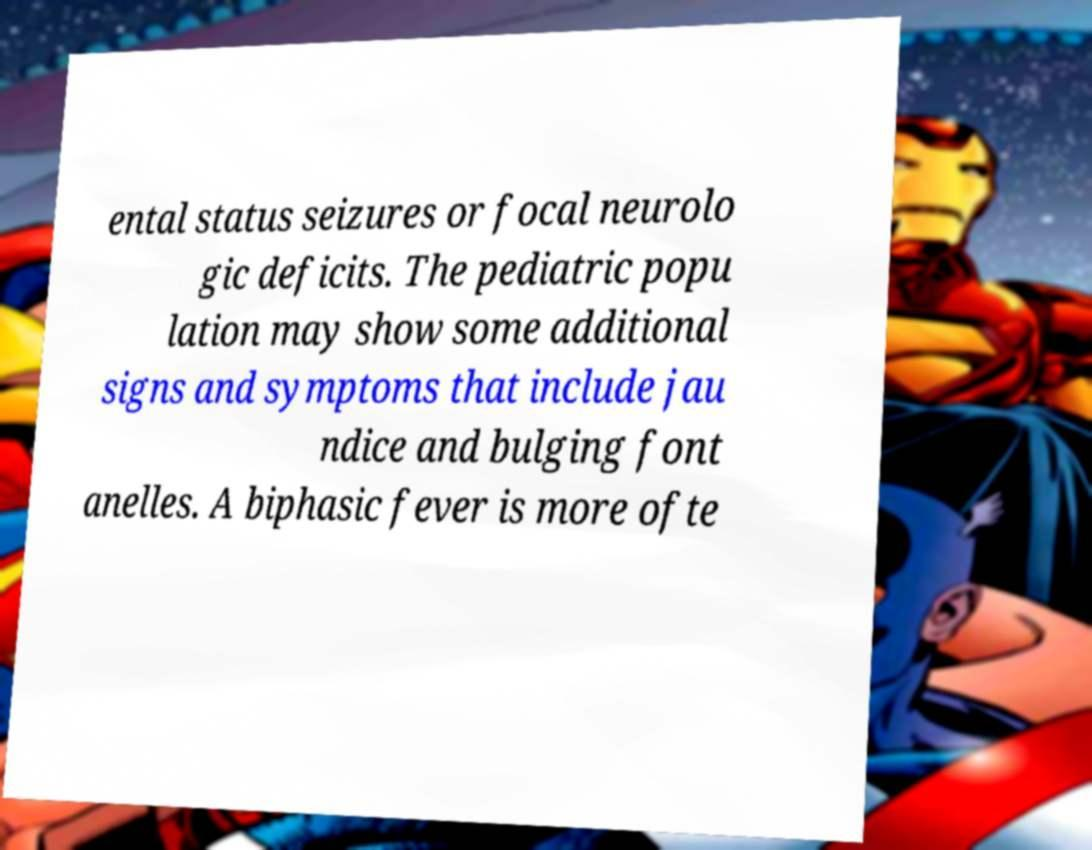For documentation purposes, I need the text within this image transcribed. Could you provide that? ental status seizures or focal neurolo gic deficits. The pediatric popu lation may show some additional signs and symptoms that include jau ndice and bulging font anelles. A biphasic fever is more ofte 